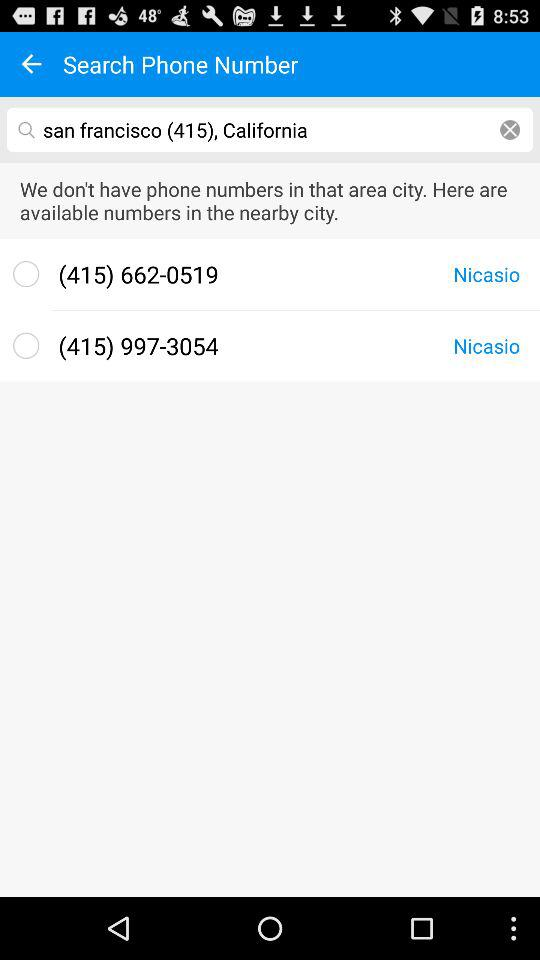How many phone numbers are displayed for Nicasio?
Answer the question using a single word or phrase. 2 